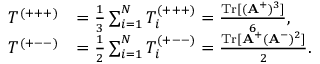Convert formula to latex. <formula><loc_0><loc_0><loc_500><loc_500>\begin{array} { r l } { T ^ { ( + + + ) } } & { = \frac { 1 } { 3 } \sum _ { i = 1 } ^ { N } T _ { i } ^ { ( + + + ) } = \frac { T r [ ( A ^ { + } ) ^ { 3 } ] } { 6 } , } \\ { T ^ { ( + - - ) } } & { = \frac { 1 } { 2 } \sum _ { i = 1 } ^ { N } T _ { i } ^ { ( + - - ) } = \frac { T r [ A ^ { + } ( A ^ { - } ) ^ { 2 } ] } { 2 } . } \end{array}</formula> 